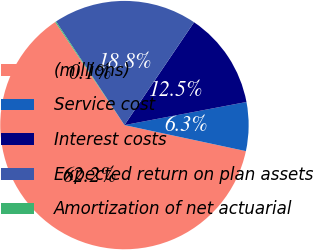Convert chart. <chart><loc_0><loc_0><loc_500><loc_500><pie_chart><fcel>(millions)<fcel>Service cost<fcel>Interest costs<fcel>Expected return on plan assets<fcel>Amortization of net actuarial<nl><fcel>62.23%<fcel>6.34%<fcel>12.55%<fcel>18.76%<fcel>0.13%<nl></chart> 